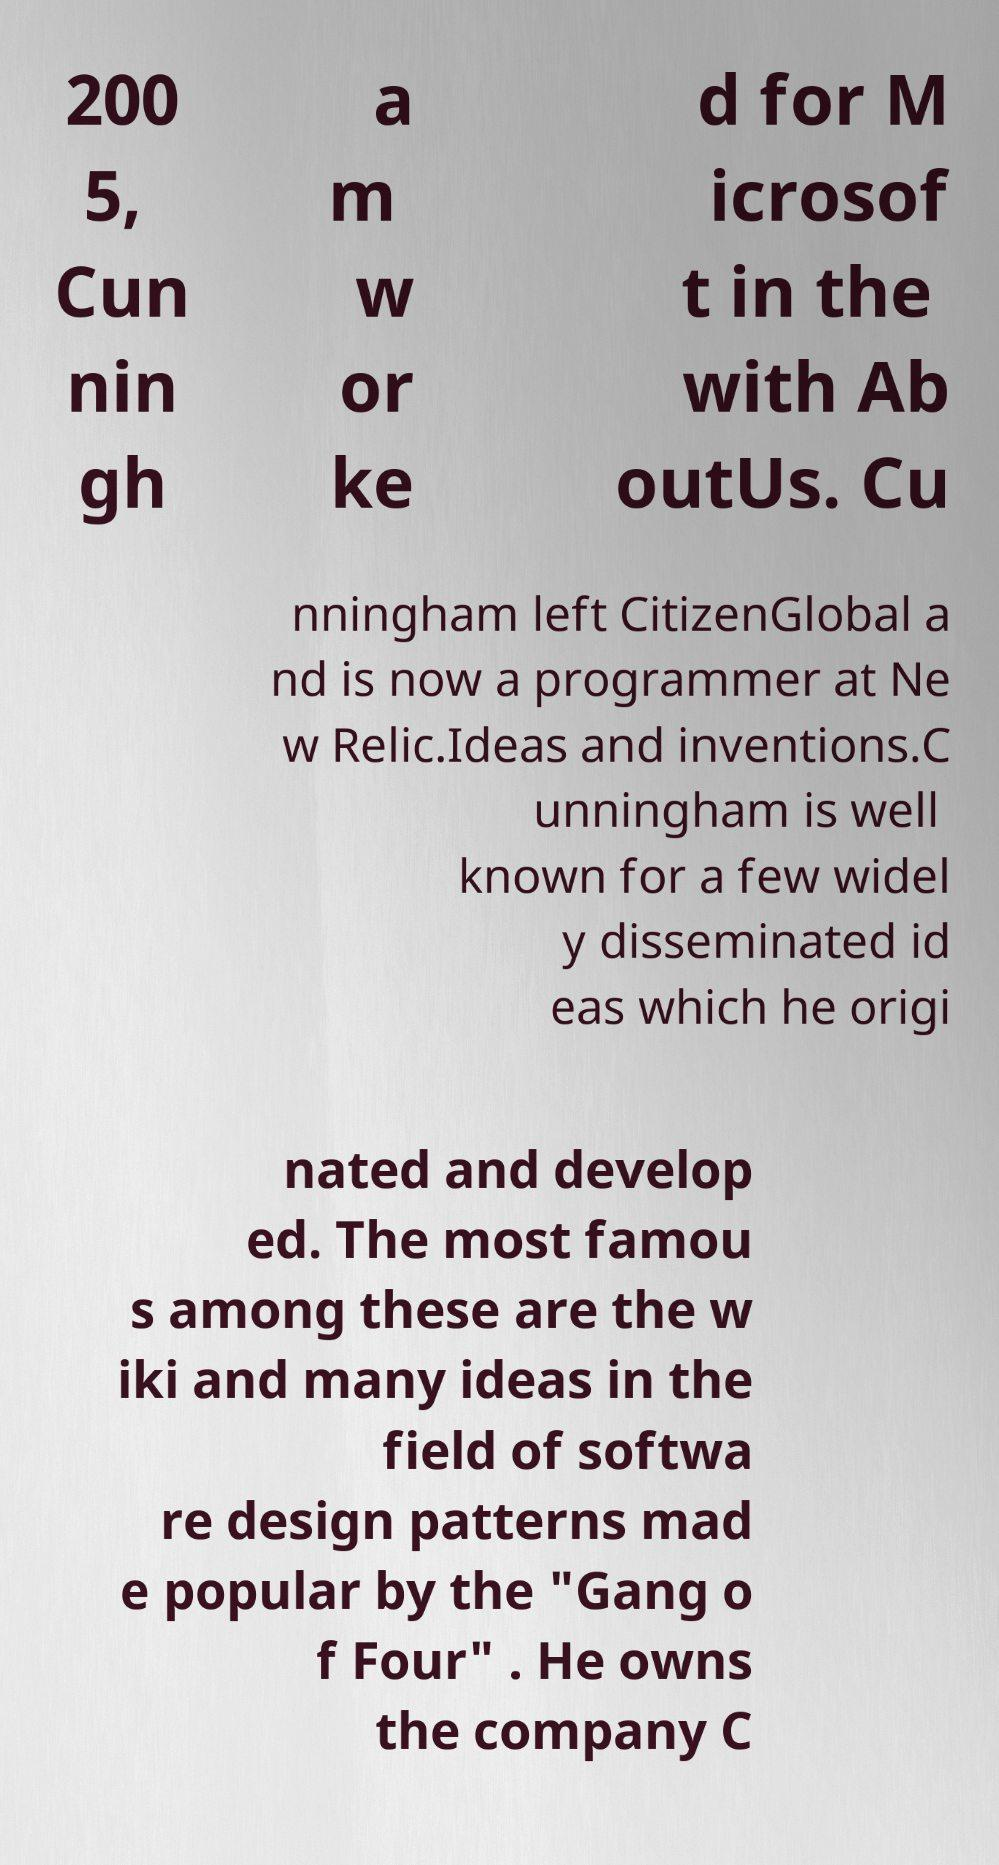Please read and relay the text visible in this image. What does it say? 200 5, Cun nin gh a m w or ke d for M icrosof t in the with Ab outUs. Cu nningham left CitizenGlobal a nd is now a programmer at Ne w Relic.Ideas and inventions.C unningham is well known for a few widel y disseminated id eas which he origi nated and develop ed. The most famou s among these are the w iki and many ideas in the field of softwa re design patterns mad e popular by the "Gang o f Four" . He owns the company C 